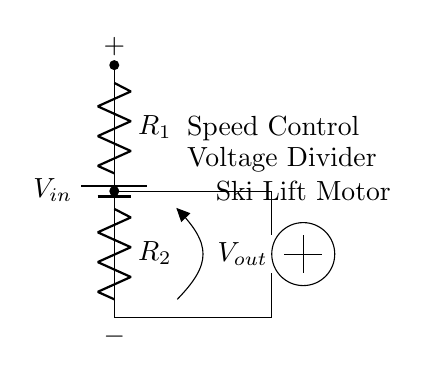What are the components of this circuit? The circuit consists of a power supply (battery), two resistors (R1 and R2), and a ski lift motor.
Answer: Battery, R1, R2, Ski Lift Motor What type of circuit is this? This is a voltage divider circuit, which is used to reduce the voltage for controlling the speed of the ski lift motor.
Answer: Voltage Divider What is the function of the resistors in this circuit? The resistors (R1 and R2) create a voltage drop, allowing the circuit to output a lower voltage from a higher input voltage, thus controlling the motor speed.
Answer: Voltage drop How does the output voltage change with respect to resistor values? The output voltage is determined by the ratio of R1 and R2 according to the voltage divider rule; increasing R2 will decrease the output voltage, while decreasing R1 will also decrease it.
Answer: Ratio of R1 and R2 What is the connection between the output voltage and the ski lift motor? The output voltage is applied directly to the ski lift motor, and altering this voltage allows for control over the motor's speed.
Answer: Direct control What is the role of the voltage divider in this circuit? The voltage divider reduces the input voltage to a level suitable for the ski lift motor, which regulates its speed based on the voltage output.
Answer: Speed control 